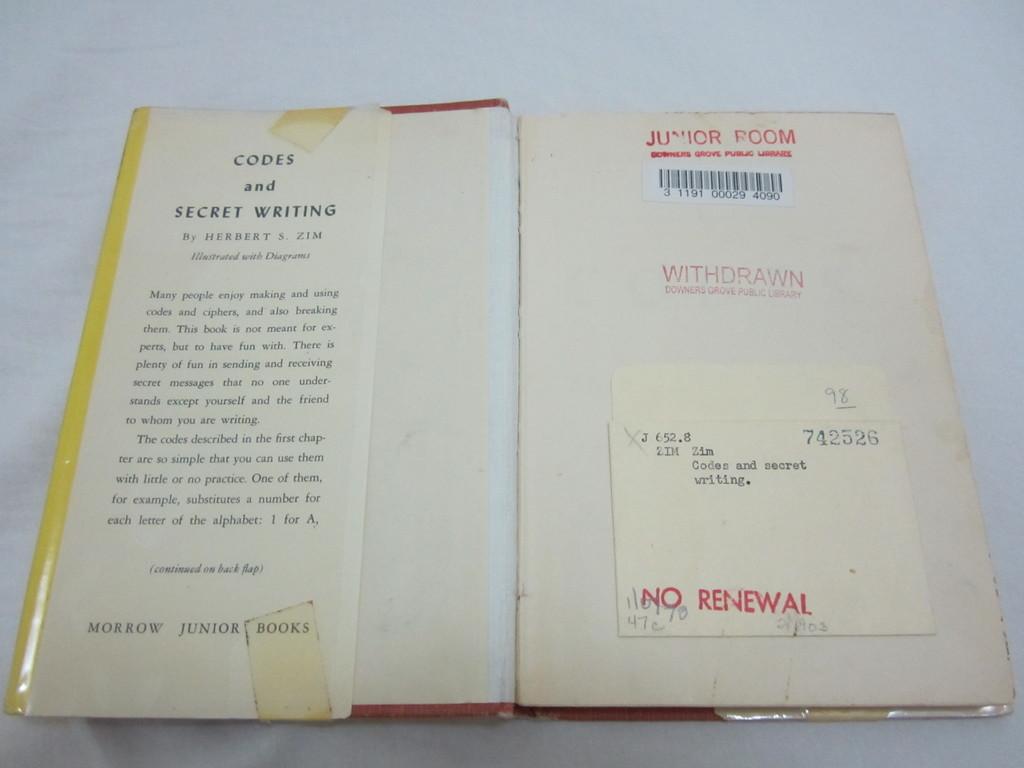What is the title of this novel?
Provide a short and direct response. Codes and secret writing. Who published the book?
Offer a terse response. Morrow junior books. 